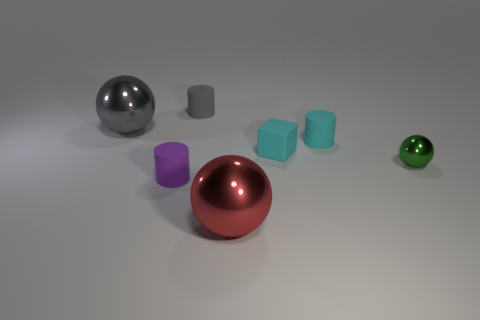Does the small matte block have the same color as the small sphere?
Ensure brevity in your answer.  No. There is a object that is the same color as the cube; what is its material?
Give a very brief answer. Rubber. Is there anything else that has the same shape as the big red shiny thing?
Keep it short and to the point. Yes. Do the red object and the big object that is to the left of the purple cylinder have the same material?
Ensure brevity in your answer.  Yes. There is a big metallic object that is on the right side of the cylinder behind the big metallic object that is to the left of the tiny purple object; what is its color?
Offer a terse response. Red. Is there any other thing that is the same size as the green metal ball?
Offer a very short reply. Yes. There is a block; does it have the same color as the big sphere behind the purple rubber thing?
Give a very brief answer. No. The small sphere is what color?
Your response must be concise. Green. There is a shiny object behind the cyan thing that is in front of the rubber thing right of the small matte block; what is its shape?
Offer a terse response. Sphere. What number of other things are the same color as the matte cube?
Your answer should be compact. 1. 